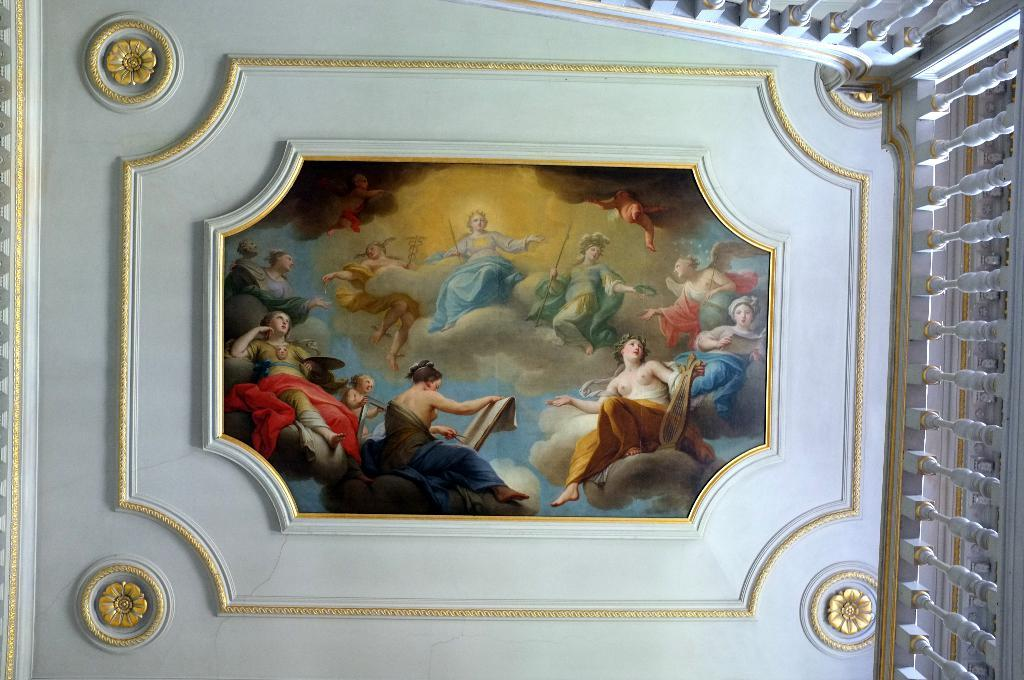What is located at the top of the structure in the image? There is a roof in the image. What is featured on the roof? There is a photo at the center of the roof. What can be seen on the right side of the image? There is a railing on the right side of the image. What type of fruit is hanging from the pipe in the image? There is no pipe or fruit present in the image. How many bottles of soda are visible on the railing in the image? There are no bottles of soda visible on the railing in the image. 